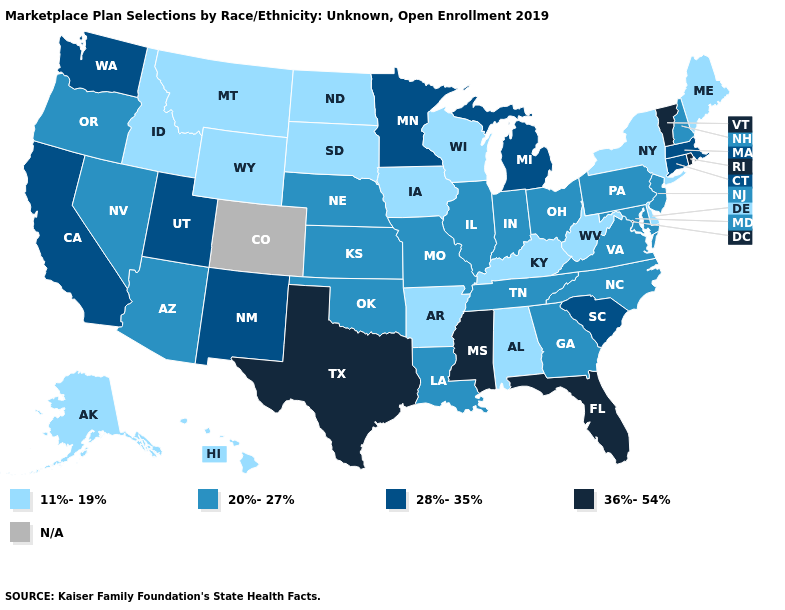What is the lowest value in the USA?
Give a very brief answer. 11%-19%. Name the states that have a value in the range 20%-27%?
Short answer required. Arizona, Georgia, Illinois, Indiana, Kansas, Louisiana, Maryland, Missouri, Nebraska, Nevada, New Hampshire, New Jersey, North Carolina, Ohio, Oklahoma, Oregon, Pennsylvania, Tennessee, Virginia. Name the states that have a value in the range 36%-54%?
Keep it brief. Florida, Mississippi, Rhode Island, Texas, Vermont. Which states have the lowest value in the USA?
Be succinct. Alabama, Alaska, Arkansas, Delaware, Hawaii, Idaho, Iowa, Kentucky, Maine, Montana, New York, North Dakota, South Dakota, West Virginia, Wisconsin, Wyoming. What is the value of Maine?
Quick response, please. 11%-19%. What is the lowest value in the South?
Short answer required. 11%-19%. What is the value of Kentucky?
Be succinct. 11%-19%. Which states have the lowest value in the USA?
Answer briefly. Alabama, Alaska, Arkansas, Delaware, Hawaii, Idaho, Iowa, Kentucky, Maine, Montana, New York, North Dakota, South Dakota, West Virginia, Wisconsin, Wyoming. What is the lowest value in the USA?
Give a very brief answer. 11%-19%. What is the value of Utah?
Give a very brief answer. 28%-35%. Name the states that have a value in the range 11%-19%?
Keep it brief. Alabama, Alaska, Arkansas, Delaware, Hawaii, Idaho, Iowa, Kentucky, Maine, Montana, New York, North Dakota, South Dakota, West Virginia, Wisconsin, Wyoming. What is the highest value in states that border Nebraska?
Concise answer only. 20%-27%. What is the value of New Mexico?
Short answer required. 28%-35%. What is the value of Hawaii?
Give a very brief answer. 11%-19%. 